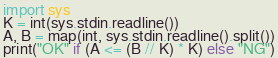<code> <loc_0><loc_0><loc_500><loc_500><_Python_>import sys
K = int(sys.stdin.readline())
A, B = map(int, sys.stdin.readline().split())
print("OK" if (A <= (B // K) * K) else "NG")
</code> 